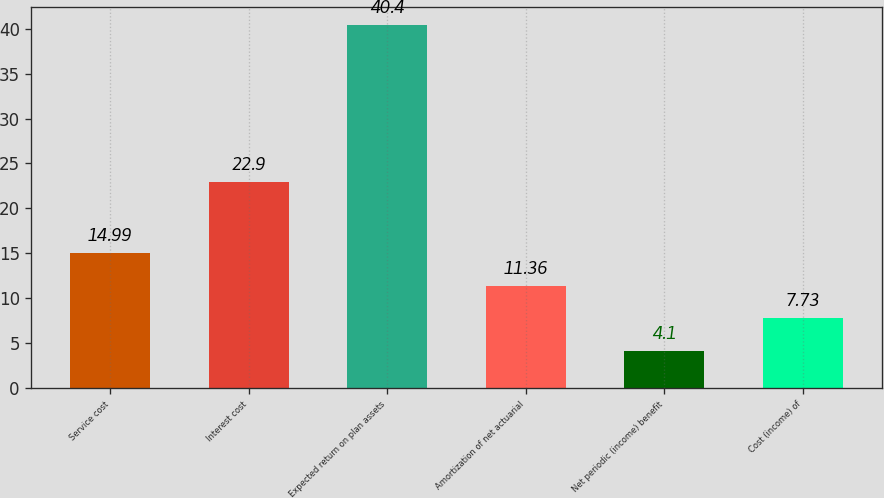Convert chart. <chart><loc_0><loc_0><loc_500><loc_500><bar_chart><fcel>Service cost<fcel>Interest cost<fcel>Expected return on plan assets<fcel>Amortization of net actuarial<fcel>Net periodic (income) benefit<fcel>Cost (income) of<nl><fcel>14.99<fcel>22.9<fcel>40.4<fcel>11.36<fcel>4.1<fcel>7.73<nl></chart> 